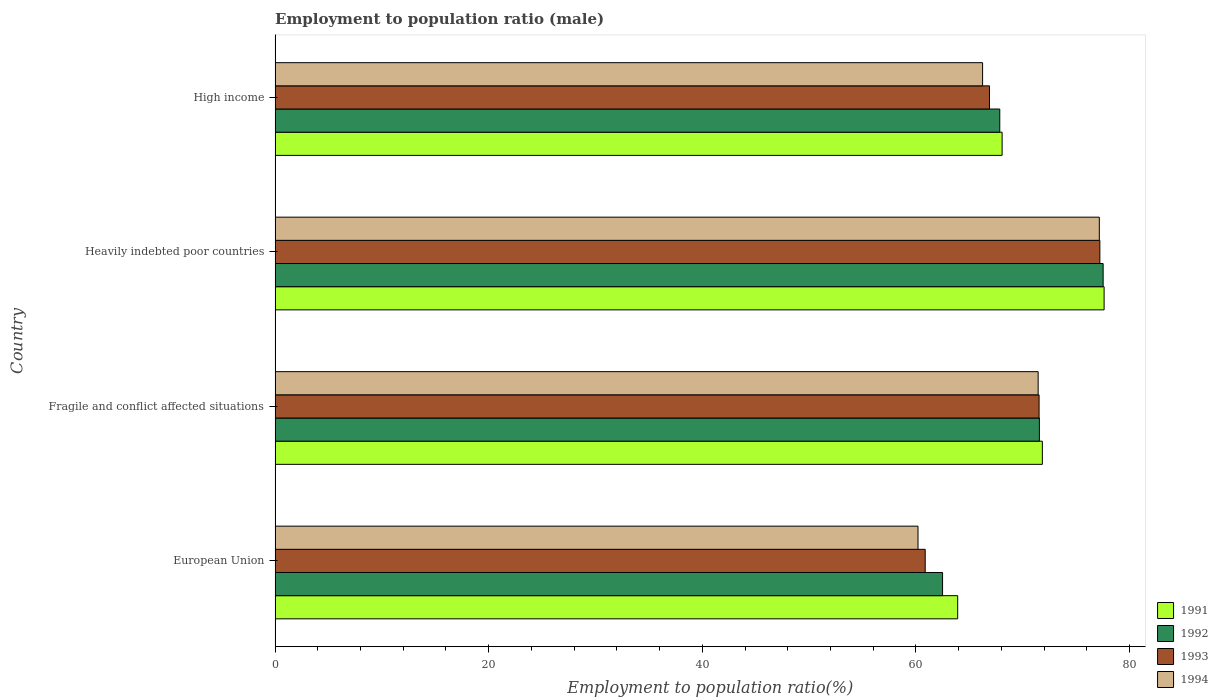How many different coloured bars are there?
Your answer should be very brief. 4. Are the number of bars per tick equal to the number of legend labels?
Make the answer very short. Yes. What is the employment to population ratio in 1994 in Fragile and conflict affected situations?
Offer a very short reply. 71.44. Across all countries, what is the maximum employment to population ratio in 1994?
Keep it short and to the point. 77.17. Across all countries, what is the minimum employment to population ratio in 1992?
Make the answer very short. 62.49. In which country was the employment to population ratio in 1993 maximum?
Provide a short and direct response. Heavily indebted poor countries. What is the total employment to population ratio in 1993 in the graph?
Give a very brief answer. 276.5. What is the difference between the employment to population ratio in 1992 in Fragile and conflict affected situations and that in Heavily indebted poor countries?
Keep it short and to the point. -5.97. What is the difference between the employment to population ratio in 1992 in Heavily indebted poor countries and the employment to population ratio in 1991 in High income?
Your answer should be very brief. 9.46. What is the average employment to population ratio in 1994 per country?
Keep it short and to the point. 68.76. What is the difference between the employment to population ratio in 1993 and employment to population ratio in 1992 in Heavily indebted poor countries?
Provide a succinct answer. -0.31. In how many countries, is the employment to population ratio in 1992 greater than 68 %?
Provide a short and direct response. 2. What is the ratio of the employment to population ratio in 1993 in Fragile and conflict affected situations to that in High income?
Give a very brief answer. 1.07. What is the difference between the highest and the second highest employment to population ratio in 1993?
Give a very brief answer. 5.69. What is the difference between the highest and the lowest employment to population ratio in 1992?
Make the answer very short. 15.03. Is it the case that in every country, the sum of the employment to population ratio in 1993 and employment to population ratio in 1994 is greater than the sum of employment to population ratio in 1991 and employment to population ratio in 1992?
Offer a very short reply. No. Is it the case that in every country, the sum of the employment to population ratio in 1991 and employment to population ratio in 1993 is greater than the employment to population ratio in 1992?
Offer a terse response. Yes. How many bars are there?
Your answer should be very brief. 16. How many countries are there in the graph?
Ensure brevity in your answer.  4. Are the values on the major ticks of X-axis written in scientific E-notation?
Your answer should be very brief. No. Does the graph contain grids?
Provide a short and direct response. No. How are the legend labels stacked?
Keep it short and to the point. Vertical. What is the title of the graph?
Provide a short and direct response. Employment to population ratio (male). Does "1974" appear as one of the legend labels in the graph?
Keep it short and to the point. No. What is the label or title of the Y-axis?
Your answer should be very brief. Country. What is the Employment to population ratio(%) of 1991 in European Union?
Your response must be concise. 63.91. What is the Employment to population ratio(%) in 1992 in European Union?
Provide a succinct answer. 62.49. What is the Employment to population ratio(%) of 1993 in European Union?
Give a very brief answer. 60.87. What is the Employment to population ratio(%) in 1994 in European Union?
Give a very brief answer. 60.19. What is the Employment to population ratio(%) of 1991 in Fragile and conflict affected situations?
Ensure brevity in your answer.  71.83. What is the Employment to population ratio(%) in 1992 in Fragile and conflict affected situations?
Ensure brevity in your answer.  71.56. What is the Employment to population ratio(%) in 1993 in Fragile and conflict affected situations?
Provide a short and direct response. 71.53. What is the Employment to population ratio(%) in 1994 in Fragile and conflict affected situations?
Keep it short and to the point. 71.44. What is the Employment to population ratio(%) of 1991 in Heavily indebted poor countries?
Make the answer very short. 77.61. What is the Employment to population ratio(%) in 1992 in Heavily indebted poor countries?
Provide a short and direct response. 77.52. What is the Employment to population ratio(%) in 1993 in Heavily indebted poor countries?
Provide a succinct answer. 77.22. What is the Employment to population ratio(%) of 1994 in Heavily indebted poor countries?
Offer a very short reply. 77.17. What is the Employment to population ratio(%) of 1991 in High income?
Your response must be concise. 68.07. What is the Employment to population ratio(%) in 1992 in High income?
Provide a succinct answer. 67.85. What is the Employment to population ratio(%) of 1993 in High income?
Make the answer very short. 66.88. What is the Employment to population ratio(%) of 1994 in High income?
Give a very brief answer. 66.24. Across all countries, what is the maximum Employment to population ratio(%) in 1991?
Offer a terse response. 77.61. Across all countries, what is the maximum Employment to population ratio(%) in 1992?
Give a very brief answer. 77.52. Across all countries, what is the maximum Employment to population ratio(%) in 1993?
Keep it short and to the point. 77.22. Across all countries, what is the maximum Employment to population ratio(%) of 1994?
Your answer should be compact. 77.17. Across all countries, what is the minimum Employment to population ratio(%) of 1991?
Your answer should be compact. 63.91. Across all countries, what is the minimum Employment to population ratio(%) of 1992?
Offer a very short reply. 62.49. Across all countries, what is the minimum Employment to population ratio(%) of 1993?
Provide a succinct answer. 60.87. Across all countries, what is the minimum Employment to population ratio(%) of 1994?
Provide a short and direct response. 60.19. What is the total Employment to population ratio(%) of 1991 in the graph?
Provide a short and direct response. 281.42. What is the total Employment to population ratio(%) in 1992 in the graph?
Ensure brevity in your answer.  279.42. What is the total Employment to population ratio(%) in 1993 in the graph?
Give a very brief answer. 276.5. What is the total Employment to population ratio(%) of 1994 in the graph?
Make the answer very short. 275.04. What is the difference between the Employment to population ratio(%) in 1991 in European Union and that in Fragile and conflict affected situations?
Provide a short and direct response. -7.93. What is the difference between the Employment to population ratio(%) of 1992 in European Union and that in Fragile and conflict affected situations?
Your answer should be very brief. -9.06. What is the difference between the Employment to population ratio(%) in 1993 in European Union and that in Fragile and conflict affected situations?
Your answer should be very brief. -10.66. What is the difference between the Employment to population ratio(%) of 1994 in European Union and that in Fragile and conflict affected situations?
Offer a terse response. -11.25. What is the difference between the Employment to population ratio(%) of 1991 in European Union and that in Heavily indebted poor countries?
Offer a terse response. -13.71. What is the difference between the Employment to population ratio(%) of 1992 in European Union and that in Heavily indebted poor countries?
Offer a terse response. -15.03. What is the difference between the Employment to population ratio(%) in 1993 in European Union and that in Heavily indebted poor countries?
Ensure brevity in your answer.  -16.35. What is the difference between the Employment to population ratio(%) of 1994 in European Union and that in Heavily indebted poor countries?
Provide a succinct answer. -16.97. What is the difference between the Employment to population ratio(%) in 1991 in European Union and that in High income?
Your answer should be very brief. -4.16. What is the difference between the Employment to population ratio(%) of 1992 in European Union and that in High income?
Ensure brevity in your answer.  -5.36. What is the difference between the Employment to population ratio(%) of 1993 in European Union and that in High income?
Ensure brevity in your answer.  -6.02. What is the difference between the Employment to population ratio(%) of 1994 in European Union and that in High income?
Ensure brevity in your answer.  -6.05. What is the difference between the Employment to population ratio(%) of 1991 in Fragile and conflict affected situations and that in Heavily indebted poor countries?
Provide a succinct answer. -5.78. What is the difference between the Employment to population ratio(%) in 1992 in Fragile and conflict affected situations and that in Heavily indebted poor countries?
Provide a short and direct response. -5.97. What is the difference between the Employment to population ratio(%) of 1993 in Fragile and conflict affected situations and that in Heavily indebted poor countries?
Offer a terse response. -5.69. What is the difference between the Employment to population ratio(%) in 1994 in Fragile and conflict affected situations and that in Heavily indebted poor countries?
Offer a very short reply. -5.73. What is the difference between the Employment to population ratio(%) in 1991 in Fragile and conflict affected situations and that in High income?
Ensure brevity in your answer.  3.77. What is the difference between the Employment to population ratio(%) in 1992 in Fragile and conflict affected situations and that in High income?
Keep it short and to the point. 3.71. What is the difference between the Employment to population ratio(%) of 1993 in Fragile and conflict affected situations and that in High income?
Provide a short and direct response. 4.64. What is the difference between the Employment to population ratio(%) in 1994 in Fragile and conflict affected situations and that in High income?
Your answer should be compact. 5.2. What is the difference between the Employment to population ratio(%) of 1991 in Heavily indebted poor countries and that in High income?
Offer a terse response. 9.55. What is the difference between the Employment to population ratio(%) in 1992 in Heavily indebted poor countries and that in High income?
Make the answer very short. 9.68. What is the difference between the Employment to population ratio(%) in 1993 in Heavily indebted poor countries and that in High income?
Offer a terse response. 10.33. What is the difference between the Employment to population ratio(%) of 1994 in Heavily indebted poor countries and that in High income?
Offer a very short reply. 10.93. What is the difference between the Employment to population ratio(%) in 1991 in European Union and the Employment to population ratio(%) in 1992 in Fragile and conflict affected situations?
Your answer should be very brief. -7.65. What is the difference between the Employment to population ratio(%) of 1991 in European Union and the Employment to population ratio(%) of 1993 in Fragile and conflict affected situations?
Provide a succinct answer. -7.62. What is the difference between the Employment to population ratio(%) in 1991 in European Union and the Employment to population ratio(%) in 1994 in Fragile and conflict affected situations?
Provide a succinct answer. -7.53. What is the difference between the Employment to population ratio(%) of 1992 in European Union and the Employment to population ratio(%) of 1993 in Fragile and conflict affected situations?
Give a very brief answer. -9.04. What is the difference between the Employment to population ratio(%) of 1992 in European Union and the Employment to population ratio(%) of 1994 in Fragile and conflict affected situations?
Offer a very short reply. -8.95. What is the difference between the Employment to population ratio(%) of 1993 in European Union and the Employment to population ratio(%) of 1994 in Fragile and conflict affected situations?
Make the answer very short. -10.58. What is the difference between the Employment to population ratio(%) in 1991 in European Union and the Employment to population ratio(%) in 1992 in Heavily indebted poor countries?
Ensure brevity in your answer.  -13.62. What is the difference between the Employment to population ratio(%) in 1991 in European Union and the Employment to population ratio(%) in 1993 in Heavily indebted poor countries?
Give a very brief answer. -13.31. What is the difference between the Employment to population ratio(%) in 1991 in European Union and the Employment to population ratio(%) in 1994 in Heavily indebted poor countries?
Provide a short and direct response. -13.26. What is the difference between the Employment to population ratio(%) in 1992 in European Union and the Employment to population ratio(%) in 1993 in Heavily indebted poor countries?
Provide a short and direct response. -14.73. What is the difference between the Employment to population ratio(%) of 1992 in European Union and the Employment to population ratio(%) of 1994 in Heavily indebted poor countries?
Give a very brief answer. -14.68. What is the difference between the Employment to population ratio(%) of 1993 in European Union and the Employment to population ratio(%) of 1994 in Heavily indebted poor countries?
Your answer should be compact. -16.3. What is the difference between the Employment to population ratio(%) of 1991 in European Union and the Employment to population ratio(%) of 1992 in High income?
Offer a terse response. -3.94. What is the difference between the Employment to population ratio(%) in 1991 in European Union and the Employment to population ratio(%) in 1993 in High income?
Offer a very short reply. -2.98. What is the difference between the Employment to population ratio(%) in 1991 in European Union and the Employment to population ratio(%) in 1994 in High income?
Provide a succinct answer. -2.33. What is the difference between the Employment to population ratio(%) in 1992 in European Union and the Employment to population ratio(%) in 1993 in High income?
Provide a short and direct response. -4.39. What is the difference between the Employment to population ratio(%) in 1992 in European Union and the Employment to population ratio(%) in 1994 in High income?
Keep it short and to the point. -3.75. What is the difference between the Employment to population ratio(%) of 1993 in European Union and the Employment to population ratio(%) of 1994 in High income?
Provide a short and direct response. -5.37. What is the difference between the Employment to population ratio(%) in 1991 in Fragile and conflict affected situations and the Employment to population ratio(%) in 1992 in Heavily indebted poor countries?
Your answer should be very brief. -5.69. What is the difference between the Employment to population ratio(%) in 1991 in Fragile and conflict affected situations and the Employment to population ratio(%) in 1993 in Heavily indebted poor countries?
Offer a terse response. -5.38. What is the difference between the Employment to population ratio(%) of 1991 in Fragile and conflict affected situations and the Employment to population ratio(%) of 1994 in Heavily indebted poor countries?
Give a very brief answer. -5.33. What is the difference between the Employment to population ratio(%) in 1992 in Fragile and conflict affected situations and the Employment to population ratio(%) in 1993 in Heavily indebted poor countries?
Your answer should be compact. -5.66. What is the difference between the Employment to population ratio(%) in 1992 in Fragile and conflict affected situations and the Employment to population ratio(%) in 1994 in Heavily indebted poor countries?
Give a very brief answer. -5.61. What is the difference between the Employment to population ratio(%) of 1993 in Fragile and conflict affected situations and the Employment to population ratio(%) of 1994 in Heavily indebted poor countries?
Provide a succinct answer. -5.64. What is the difference between the Employment to population ratio(%) in 1991 in Fragile and conflict affected situations and the Employment to population ratio(%) in 1992 in High income?
Provide a succinct answer. 3.99. What is the difference between the Employment to population ratio(%) in 1991 in Fragile and conflict affected situations and the Employment to population ratio(%) in 1993 in High income?
Your response must be concise. 4.95. What is the difference between the Employment to population ratio(%) in 1991 in Fragile and conflict affected situations and the Employment to population ratio(%) in 1994 in High income?
Offer a terse response. 5.6. What is the difference between the Employment to population ratio(%) of 1992 in Fragile and conflict affected situations and the Employment to population ratio(%) of 1993 in High income?
Keep it short and to the point. 4.67. What is the difference between the Employment to population ratio(%) of 1992 in Fragile and conflict affected situations and the Employment to population ratio(%) of 1994 in High income?
Your answer should be compact. 5.32. What is the difference between the Employment to population ratio(%) in 1993 in Fragile and conflict affected situations and the Employment to population ratio(%) in 1994 in High income?
Your answer should be compact. 5.29. What is the difference between the Employment to population ratio(%) of 1991 in Heavily indebted poor countries and the Employment to population ratio(%) of 1992 in High income?
Make the answer very short. 9.77. What is the difference between the Employment to population ratio(%) of 1991 in Heavily indebted poor countries and the Employment to population ratio(%) of 1993 in High income?
Your answer should be very brief. 10.73. What is the difference between the Employment to population ratio(%) of 1991 in Heavily indebted poor countries and the Employment to population ratio(%) of 1994 in High income?
Keep it short and to the point. 11.38. What is the difference between the Employment to population ratio(%) of 1992 in Heavily indebted poor countries and the Employment to population ratio(%) of 1993 in High income?
Your response must be concise. 10.64. What is the difference between the Employment to population ratio(%) in 1992 in Heavily indebted poor countries and the Employment to population ratio(%) in 1994 in High income?
Your answer should be compact. 11.29. What is the difference between the Employment to population ratio(%) of 1993 in Heavily indebted poor countries and the Employment to population ratio(%) of 1994 in High income?
Your answer should be very brief. 10.98. What is the average Employment to population ratio(%) of 1991 per country?
Provide a succinct answer. 70.36. What is the average Employment to population ratio(%) of 1992 per country?
Give a very brief answer. 69.85. What is the average Employment to population ratio(%) of 1993 per country?
Keep it short and to the point. 69.12. What is the average Employment to population ratio(%) of 1994 per country?
Keep it short and to the point. 68.76. What is the difference between the Employment to population ratio(%) of 1991 and Employment to population ratio(%) of 1992 in European Union?
Offer a terse response. 1.42. What is the difference between the Employment to population ratio(%) in 1991 and Employment to population ratio(%) in 1993 in European Union?
Your answer should be compact. 3.04. What is the difference between the Employment to population ratio(%) in 1991 and Employment to population ratio(%) in 1994 in European Union?
Give a very brief answer. 3.71. What is the difference between the Employment to population ratio(%) in 1992 and Employment to population ratio(%) in 1993 in European Union?
Provide a short and direct response. 1.62. What is the difference between the Employment to population ratio(%) in 1992 and Employment to population ratio(%) in 1994 in European Union?
Provide a short and direct response. 2.3. What is the difference between the Employment to population ratio(%) in 1993 and Employment to population ratio(%) in 1994 in European Union?
Your answer should be very brief. 0.67. What is the difference between the Employment to population ratio(%) of 1991 and Employment to population ratio(%) of 1992 in Fragile and conflict affected situations?
Your response must be concise. 0.28. What is the difference between the Employment to population ratio(%) of 1991 and Employment to population ratio(%) of 1993 in Fragile and conflict affected situations?
Give a very brief answer. 0.31. What is the difference between the Employment to population ratio(%) in 1991 and Employment to population ratio(%) in 1994 in Fragile and conflict affected situations?
Provide a short and direct response. 0.39. What is the difference between the Employment to population ratio(%) in 1992 and Employment to population ratio(%) in 1993 in Fragile and conflict affected situations?
Provide a short and direct response. 0.03. What is the difference between the Employment to population ratio(%) of 1992 and Employment to population ratio(%) of 1994 in Fragile and conflict affected situations?
Your response must be concise. 0.11. What is the difference between the Employment to population ratio(%) of 1993 and Employment to population ratio(%) of 1994 in Fragile and conflict affected situations?
Make the answer very short. 0.09. What is the difference between the Employment to population ratio(%) of 1991 and Employment to population ratio(%) of 1992 in Heavily indebted poor countries?
Make the answer very short. 0.09. What is the difference between the Employment to population ratio(%) of 1991 and Employment to population ratio(%) of 1993 in Heavily indebted poor countries?
Give a very brief answer. 0.4. What is the difference between the Employment to population ratio(%) of 1991 and Employment to population ratio(%) of 1994 in Heavily indebted poor countries?
Provide a short and direct response. 0.45. What is the difference between the Employment to population ratio(%) in 1992 and Employment to population ratio(%) in 1993 in Heavily indebted poor countries?
Your answer should be compact. 0.31. What is the difference between the Employment to population ratio(%) in 1992 and Employment to population ratio(%) in 1994 in Heavily indebted poor countries?
Make the answer very short. 0.36. What is the difference between the Employment to population ratio(%) in 1993 and Employment to population ratio(%) in 1994 in Heavily indebted poor countries?
Keep it short and to the point. 0.05. What is the difference between the Employment to population ratio(%) of 1991 and Employment to population ratio(%) of 1992 in High income?
Provide a short and direct response. 0.22. What is the difference between the Employment to population ratio(%) in 1991 and Employment to population ratio(%) in 1993 in High income?
Your answer should be very brief. 1.18. What is the difference between the Employment to population ratio(%) of 1991 and Employment to population ratio(%) of 1994 in High income?
Keep it short and to the point. 1.83. What is the difference between the Employment to population ratio(%) in 1992 and Employment to population ratio(%) in 1994 in High income?
Give a very brief answer. 1.61. What is the difference between the Employment to population ratio(%) in 1993 and Employment to population ratio(%) in 1994 in High income?
Offer a very short reply. 0.65. What is the ratio of the Employment to population ratio(%) in 1991 in European Union to that in Fragile and conflict affected situations?
Ensure brevity in your answer.  0.89. What is the ratio of the Employment to population ratio(%) in 1992 in European Union to that in Fragile and conflict affected situations?
Keep it short and to the point. 0.87. What is the ratio of the Employment to population ratio(%) of 1993 in European Union to that in Fragile and conflict affected situations?
Give a very brief answer. 0.85. What is the ratio of the Employment to population ratio(%) in 1994 in European Union to that in Fragile and conflict affected situations?
Give a very brief answer. 0.84. What is the ratio of the Employment to population ratio(%) of 1991 in European Union to that in Heavily indebted poor countries?
Offer a terse response. 0.82. What is the ratio of the Employment to population ratio(%) of 1992 in European Union to that in Heavily indebted poor countries?
Ensure brevity in your answer.  0.81. What is the ratio of the Employment to population ratio(%) of 1993 in European Union to that in Heavily indebted poor countries?
Ensure brevity in your answer.  0.79. What is the ratio of the Employment to population ratio(%) in 1994 in European Union to that in Heavily indebted poor countries?
Keep it short and to the point. 0.78. What is the ratio of the Employment to population ratio(%) in 1991 in European Union to that in High income?
Provide a short and direct response. 0.94. What is the ratio of the Employment to population ratio(%) of 1992 in European Union to that in High income?
Provide a succinct answer. 0.92. What is the ratio of the Employment to population ratio(%) in 1993 in European Union to that in High income?
Your response must be concise. 0.91. What is the ratio of the Employment to population ratio(%) of 1994 in European Union to that in High income?
Ensure brevity in your answer.  0.91. What is the ratio of the Employment to population ratio(%) in 1991 in Fragile and conflict affected situations to that in Heavily indebted poor countries?
Provide a succinct answer. 0.93. What is the ratio of the Employment to population ratio(%) of 1992 in Fragile and conflict affected situations to that in Heavily indebted poor countries?
Ensure brevity in your answer.  0.92. What is the ratio of the Employment to population ratio(%) in 1993 in Fragile and conflict affected situations to that in Heavily indebted poor countries?
Keep it short and to the point. 0.93. What is the ratio of the Employment to population ratio(%) of 1994 in Fragile and conflict affected situations to that in Heavily indebted poor countries?
Offer a terse response. 0.93. What is the ratio of the Employment to population ratio(%) of 1991 in Fragile and conflict affected situations to that in High income?
Keep it short and to the point. 1.06. What is the ratio of the Employment to population ratio(%) of 1992 in Fragile and conflict affected situations to that in High income?
Keep it short and to the point. 1.05. What is the ratio of the Employment to population ratio(%) in 1993 in Fragile and conflict affected situations to that in High income?
Provide a succinct answer. 1.07. What is the ratio of the Employment to population ratio(%) in 1994 in Fragile and conflict affected situations to that in High income?
Offer a very short reply. 1.08. What is the ratio of the Employment to population ratio(%) of 1991 in Heavily indebted poor countries to that in High income?
Your answer should be very brief. 1.14. What is the ratio of the Employment to population ratio(%) in 1992 in Heavily indebted poor countries to that in High income?
Your response must be concise. 1.14. What is the ratio of the Employment to population ratio(%) of 1993 in Heavily indebted poor countries to that in High income?
Make the answer very short. 1.15. What is the ratio of the Employment to population ratio(%) of 1994 in Heavily indebted poor countries to that in High income?
Give a very brief answer. 1.17. What is the difference between the highest and the second highest Employment to population ratio(%) of 1991?
Give a very brief answer. 5.78. What is the difference between the highest and the second highest Employment to population ratio(%) in 1992?
Provide a short and direct response. 5.97. What is the difference between the highest and the second highest Employment to population ratio(%) of 1993?
Offer a very short reply. 5.69. What is the difference between the highest and the second highest Employment to population ratio(%) of 1994?
Your response must be concise. 5.73. What is the difference between the highest and the lowest Employment to population ratio(%) in 1991?
Provide a succinct answer. 13.71. What is the difference between the highest and the lowest Employment to population ratio(%) of 1992?
Make the answer very short. 15.03. What is the difference between the highest and the lowest Employment to population ratio(%) of 1993?
Give a very brief answer. 16.35. What is the difference between the highest and the lowest Employment to population ratio(%) in 1994?
Give a very brief answer. 16.97. 